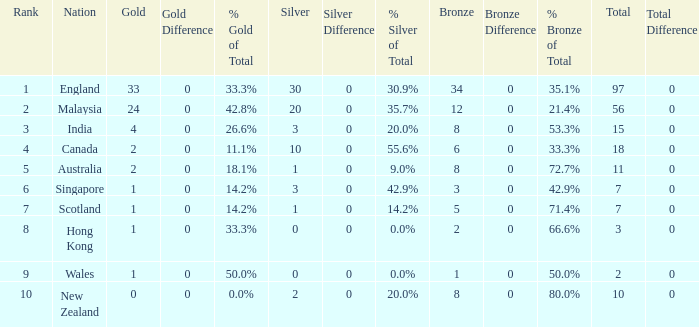What is the average silver medals a team that has 1 gold and more than 5 bronze has? None. 